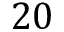Convert formula to latex. <formula><loc_0><loc_0><loc_500><loc_500>2 0</formula> 